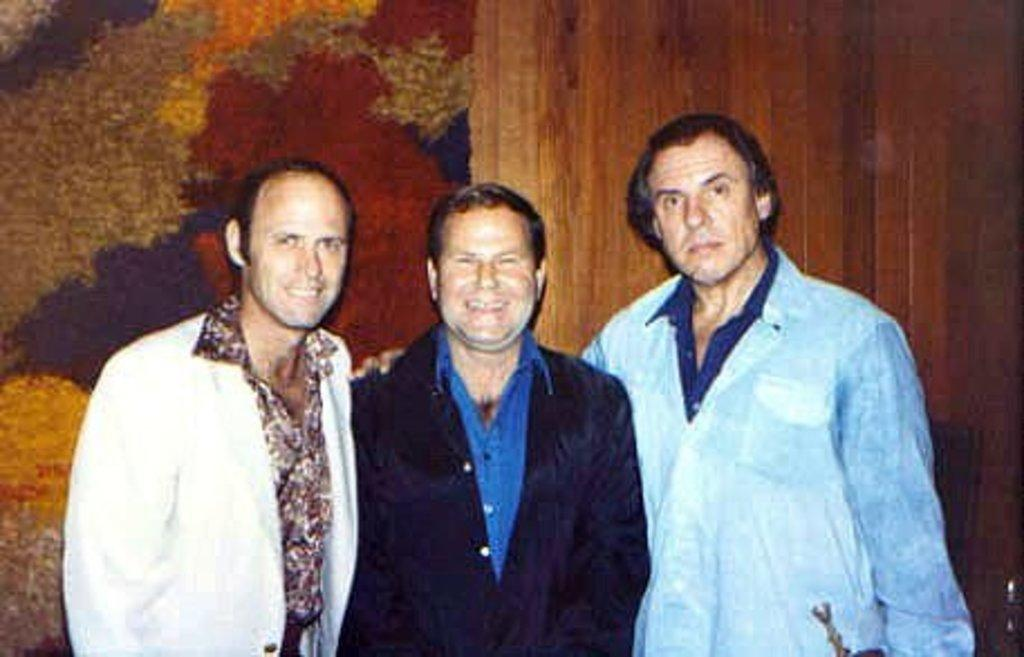How many people are in the image? There are three persons standing in the image. Where are the three persons located in the image? The three persons are at the bottom of the image. What can be seen in the background of the image? There is a wall in the background of the image. What type of order are the three persons following in the image? There is no indication of any order or sequence in the image; the three persons are simply standing. 